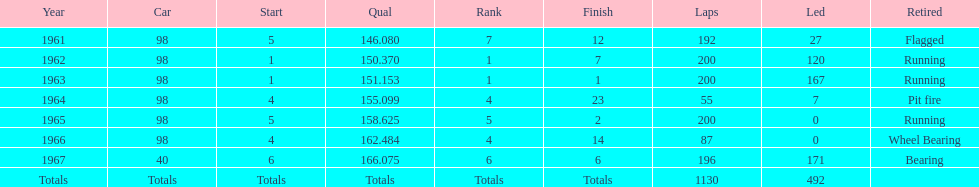What year(s) did parnelli finish at least 4th or better? 1963, 1965. 